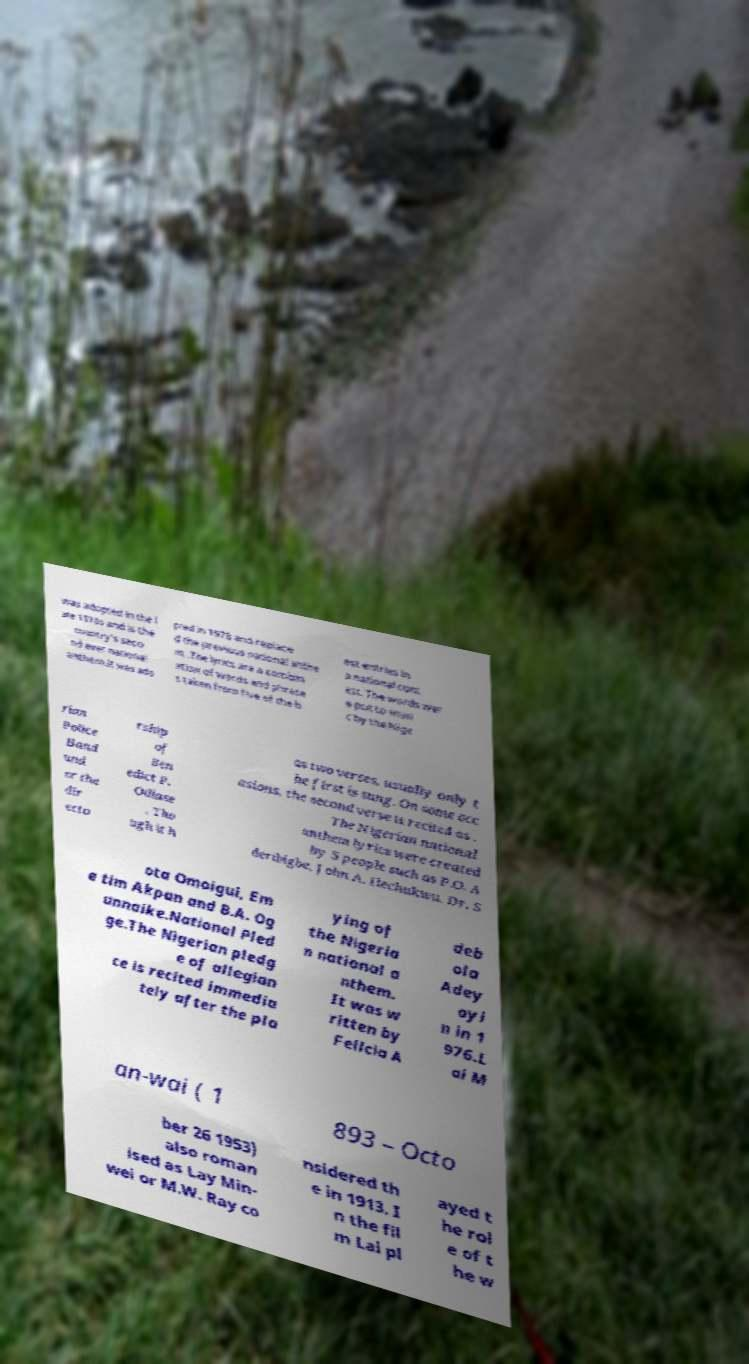Could you extract and type out the text from this image? was adopted in the l ate 1970s and is the country's seco nd ever national anthem.It was ado pted in 1978 and replace d the previous national anthe m, .The lyrics are a combin ation of words and phrase s taken from five of the b est entries in a national cont est. The words wer e put to musi c by the Nige rian Police Band und er the dir ecto rship of Ben edict P. Odiase . Tho ugh it h as two verses, usually only t he first is sung. On some occ asions, the second verse is recited as . The Nigerian national anthem lyrics were created by 5 people such as P.O. A deribigbe, John A. Ilechukwu, Dr. S ota Omoigui, Em e tim Akpan and B.A. Og unnaike.National Pled ge.The Nigerian pledg e of allegian ce is recited immedia tely after the pla ying of the Nigeria n national a nthem. It was w ritten by Felicia A deb ola Adey oyi n in 1 976.L ai M an-wai ( 1 893 – Octo ber 26 1953) also roman ised as Lay Min- wei or M.W. Ray co nsidered th e in 1913. I n the fil m Lai pl ayed t he rol e of t he w 